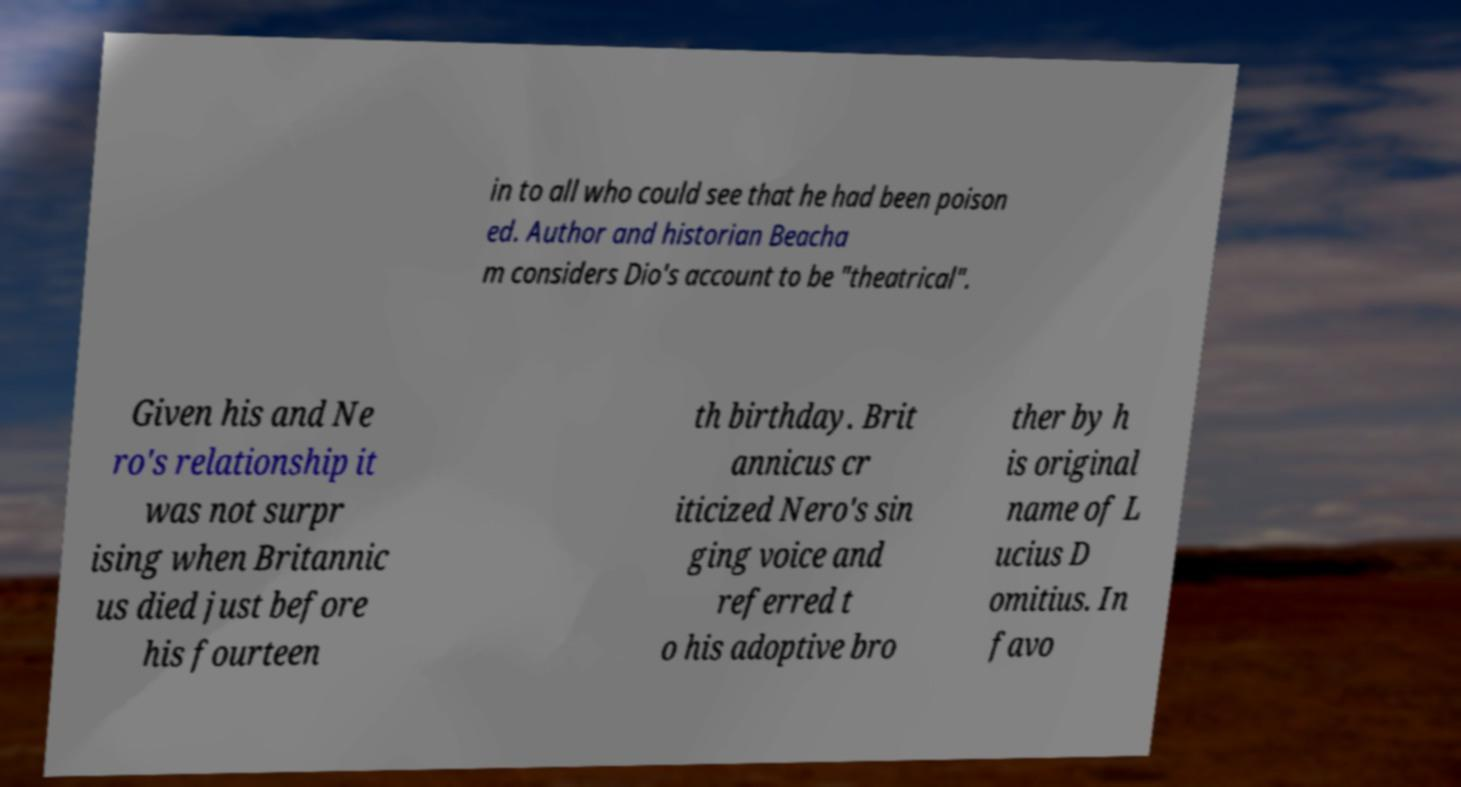There's text embedded in this image that I need extracted. Can you transcribe it verbatim? in to all who could see that he had been poison ed. Author and historian Beacha m considers Dio's account to be "theatrical". Given his and Ne ro's relationship it was not surpr ising when Britannic us died just before his fourteen th birthday. Brit annicus cr iticized Nero's sin ging voice and referred t o his adoptive bro ther by h is original name of L ucius D omitius. In favo 